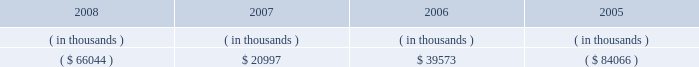Entergy mississippi , inc .
Management's financial discussion and analysis sources of capital entergy mississippi's sources to meet its capital requirements include : internally generated funds ; cash on hand ; debt or preferred stock issuances ; and bank financing under new or existing facilities .
Entergy mississippi may refinance or redeem debt and preferred stock prior to maturity , to the extent market conditions and interest and dividend rates are favorable .
All debt and common and preferred stock issuances by entergy mississippi require prior regulatory approval .
Preferred stock and debt issuances are also subject to issuance tests set forth in its corporate charter , bond indenture , and other agreements .
Entergy mississippi has sufficient capacity under these tests to meet its foreseeable capital needs .
Entergy mississippi has two separate credit facilities in the aggregate amount of $ 50 million and renewed both facilities through may 2009 .
Borrowings under the credit facilities may be secured by a security interest in entergy mississippi's accounts receivable .
No borrowings were outstanding under either credit facility as of december 31 , 2008 .
Entergy mississippi has obtained short-term borrowing authorization from the ferc under which it may borrow through march 31 , 2010 , up to the aggregate amount , at any one time outstanding , of $ 175 million .
See note 4 to the financial statements for further discussion of entergy mississippi's short-term borrowing limits .
Entergy mississippi has also obtained an order from the ferc authorizing long-term securities issuances .
The current long-term authorization extends through june 30 , 2009 .
Entergy mississippi's receivables from or ( payables to ) the money pool were as follows as of december 31 for each of the following years: .
In may 2007 , $ 6.6 million of entergy mississippi's receivable from the money pool was replaced by a note receivable from entergy new orleans .
See note 4 to the financial statements for a description of the money pool .
State and local rate regulation the rates that entergy mississippi charges for electricity significantly influence its financial position , results of operations , and liquidity .
Entergy mississippi is regulated and the rates charged to its customers are determined in regulatory proceedings .
A governmental agency , the mpsc , is primarily responsible for approval of the rates charged to customers .
Formula rate plan in march 2008 , entergy mississippi made its annual scheduled formula rate plan filing for the 2007 test year with the mpsc .
The filing showed that a $ 10.1 million increase in annual electric revenues is warranted .
In june 2008 , entergy mississippi reached a settlement with the mississippi public utilities staff that would result in a $ 3.8 million rate increase .
In january 2009 the mpsc rejected the settlement and left the current rates in effect .
Entergy mississippi appealed the mpsc's decision to the mississippi supreme court. .
How is the cash flow of entergy mississippi affected by the balance in money pool from 2006 to 2007? 
Computations: (39573 - 20997)
Answer: 18576.0. Entergy mississippi , inc .
Management's financial discussion and analysis sources of capital entergy mississippi's sources to meet its capital requirements include : internally generated funds ; cash on hand ; debt or preferred stock issuances ; and bank financing under new or existing facilities .
Entergy mississippi may refinance or redeem debt and preferred stock prior to maturity , to the extent market conditions and interest and dividend rates are favorable .
All debt and common and preferred stock issuances by entergy mississippi require prior regulatory approval .
Preferred stock and debt issuances are also subject to issuance tests set forth in its corporate charter , bond indenture , and other agreements .
Entergy mississippi has sufficient capacity under these tests to meet its foreseeable capital needs .
Entergy mississippi has two separate credit facilities in the aggregate amount of $ 50 million and renewed both facilities through may 2009 .
Borrowings under the credit facilities may be secured by a security interest in entergy mississippi's accounts receivable .
No borrowings were outstanding under either credit facility as of december 31 , 2008 .
Entergy mississippi has obtained short-term borrowing authorization from the ferc under which it may borrow through march 31 , 2010 , up to the aggregate amount , at any one time outstanding , of $ 175 million .
See note 4 to the financial statements for further discussion of entergy mississippi's short-term borrowing limits .
Entergy mississippi has also obtained an order from the ferc authorizing long-term securities issuances .
The current long-term authorization extends through june 30 , 2009 .
Entergy mississippi's receivables from or ( payables to ) the money pool were as follows as of december 31 for each of the following years: .
In may 2007 , $ 6.6 million of entergy mississippi's receivable from the money pool was replaced by a note receivable from entergy new orleans .
See note 4 to the financial statements for a description of the money pool .
State and local rate regulation the rates that entergy mississippi charges for electricity significantly influence its financial position , results of operations , and liquidity .
Entergy mississippi is regulated and the rates charged to its customers are determined in regulatory proceedings .
A governmental agency , the mpsc , is primarily responsible for approval of the rates charged to customers .
Formula rate plan in march 2008 , entergy mississippi made its annual scheduled formula rate plan filing for the 2007 test year with the mpsc .
The filing showed that a $ 10.1 million increase in annual electric revenues is warranted .
In june 2008 , entergy mississippi reached a settlement with the mississippi public utilities staff that would result in a $ 3.8 million rate increase .
In january 2009 the mpsc rejected the settlement and left the current rates in effect .
Entergy mississippi appealed the mpsc's decision to the mississippi supreme court. .
How is the cash flow of entergy mississippi affected by the balance in money pool from 2006 to 2007? 
Computations: (39573 - 20997)
Answer: 18576.0. 